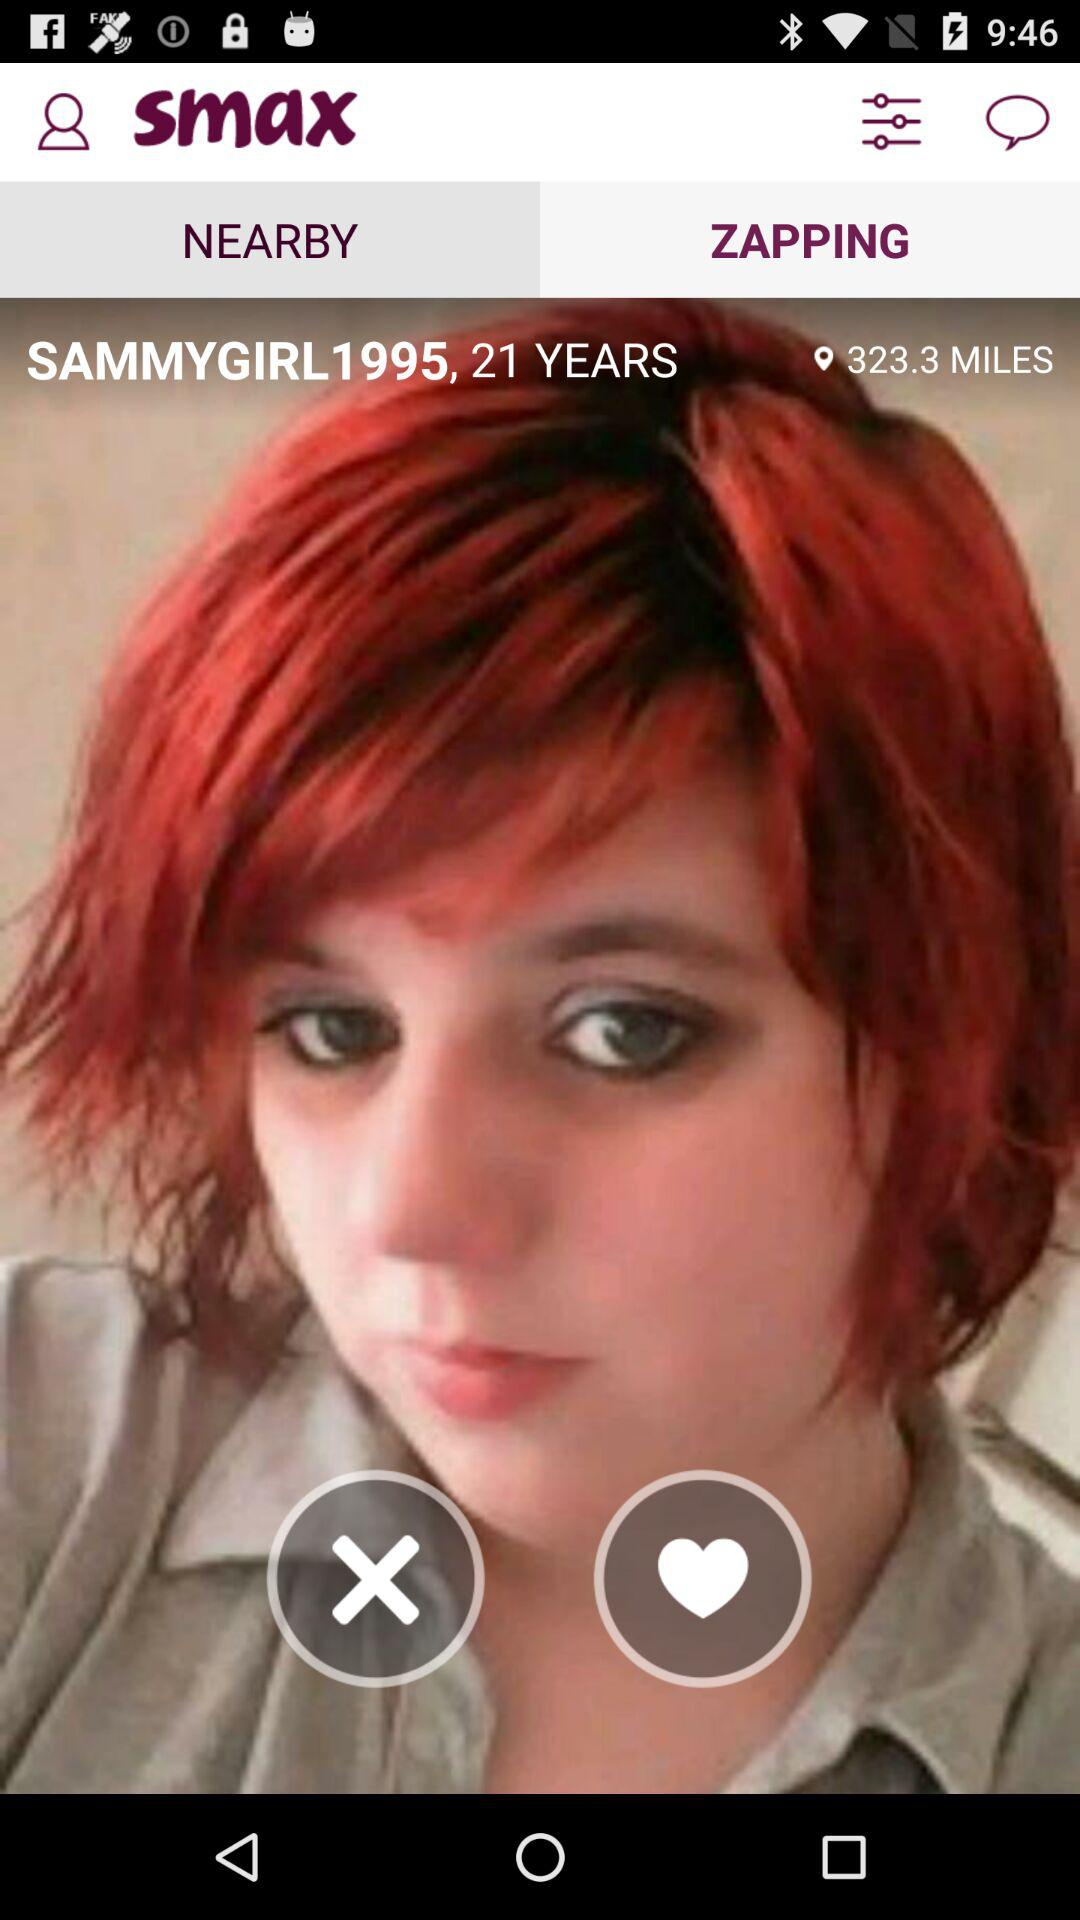What is the username? The username is "SAMMYGIRL1995". 